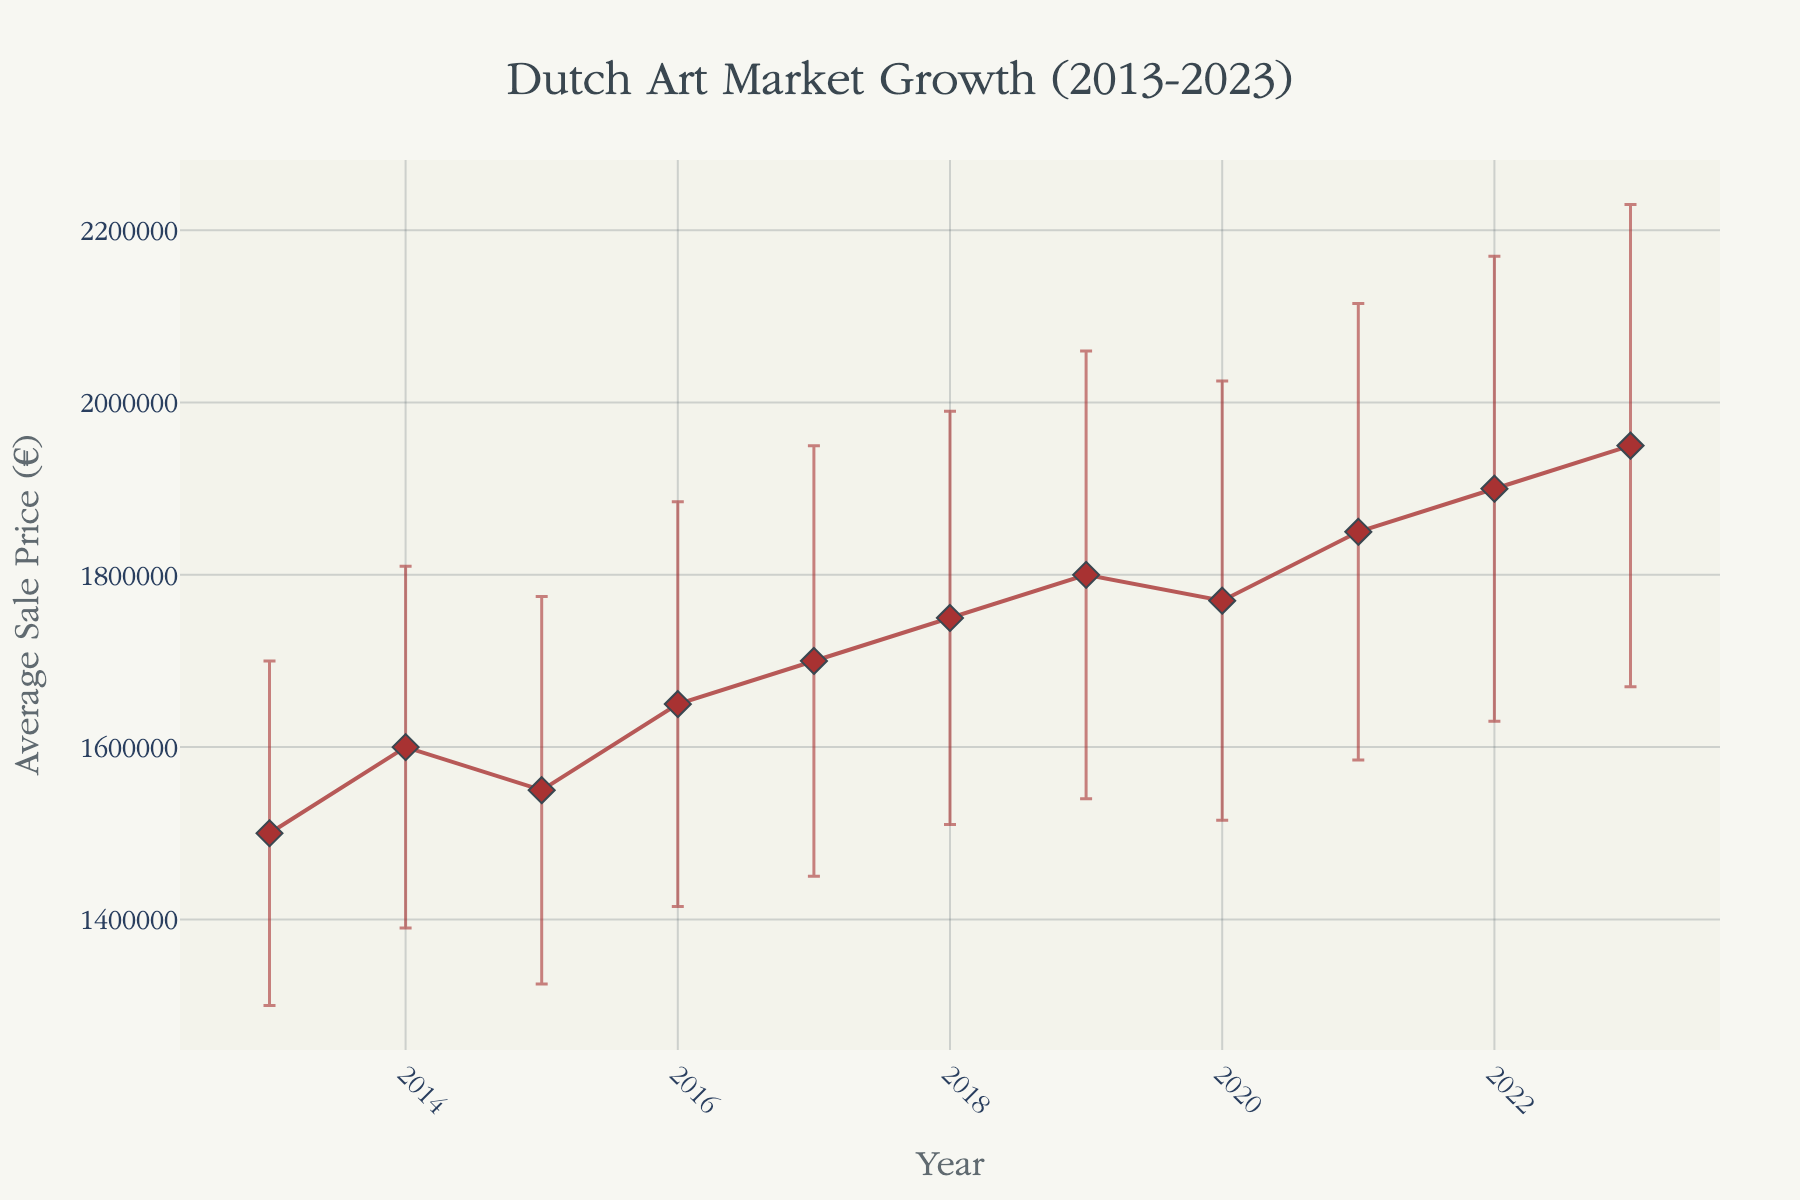What is the title of the plot? The title is located at the top of the plot and centrally aligned. It indicates the subject of the plot, which is the growth of the Dutch art market over a specific period.
Answer: Dutch Art Market Growth (2013-2023) What is the average sale price in 2023? The y-axis represents the average sale price in euros, and you can find the value for the year 2023 on the plot.
Answer: €1,950,000 Which year had the lowest average sale price? By comparing the y-values (average sale prices) for all the years on the plot, identify the lowest point.
Answer: 2013 What is the difference in average sale price between 2020 and 2022? Find the average sale price for 2020 and 2022 from the y-axis, then subtract the 2020 value from the 2022 value.
Answer: €130,000 How does the average sale price in 2021 compare to that in 2019? Locate the average sale prices for 2021 and 2019 on the y-axis, then compare the two values to see which is higher.
Answer: 2021 is higher How much did the standard deviation increase from 2013 to 2023? Locate the standard deviations for 2013 and 2023 from the error bars. Calculate the difference between these two values.
Answer: €80,000 In which year did the average sale price first reach €1,800,000? Scan through the plot to find the first year where the y-value equals or exceeds €1,800,000.
Answer: 2019 How consistent was the average sale price trend from 2013 to 2023? Observe the overall trend of the plot. Consistency can be inferred by how steady the line is, with fewer drastic changes in direction or magnitude.
Answer: Generally increasing Which year showed a decrease in the average sale price compared to the previous year? Examine the plot for any year where the y-value is less than that of the previous year.
Answer: 2020 What is the overall trend observed in the error bars from 2013 to 2023? Notice how the lengths of the error bars change over the years. This will indicate the trend in variability in sale prices.
Answer: Increasing trend 